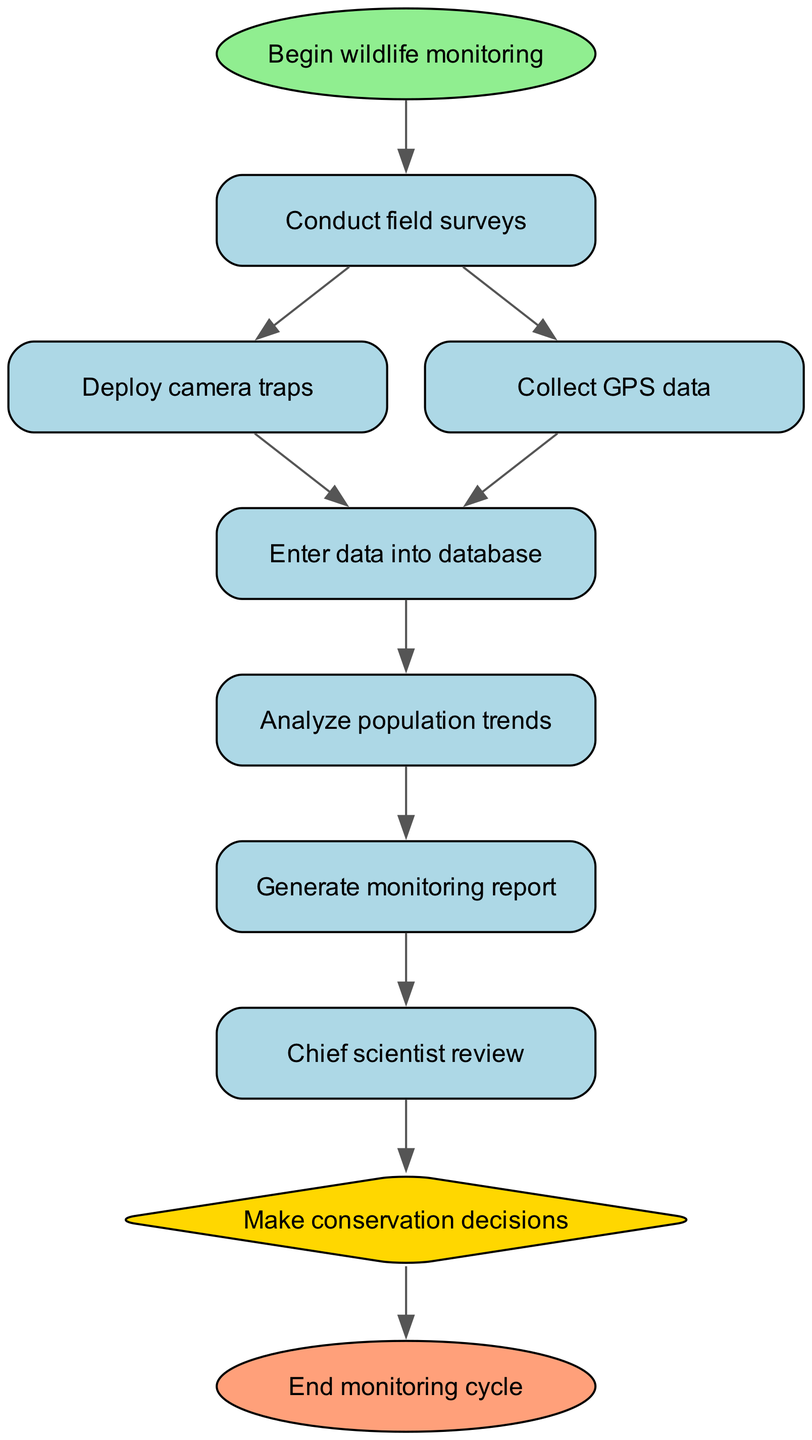What is the first step in the wildlife monitoring process? The diagram indicates that the first step is represented by the 'start' node, which states "Begin wildlife monitoring." Hence, this is the initial action taken in the process.
Answer: Begin wildlife monitoring How many nodes are present in the diagram? Counting the nodes listed, there are a total of 10 unique nodes that correspond to various steps within the wildlife monitoring process.
Answer: 10 What follows the data entry step? The diagram shows that after the 'dataEntry' node, the next process is represented by the 'analysis' node, which indicates that population trends will be analyzed after data is entered.
Answer: Analyze population trends What is the shape of the decision node? The diagram specifies that the 'decision' node is shaped as a diamond, which is a common representation for decision points in flowcharts.
Answer: Diamond How many distinct methods for data collection are outlined in the diagram? The diagram lists two separate methods for data collection: 'Conduct field surveys' and 'Deploy camera traps' in addition to 'Collect GPS data', making a total of three distinct methods illustrated in the process.
Answer: 3 Which node does the 'Chief scientist review' lead to? The 'Chief scientist review' node directly leads to the 'Make conservation decisions' node, indicating that the review is part of the decision-making process.
Answer: Make conservation decisions What is the final step in the wildlife monitoring process? The final node, labeled 'end', signifies the completion of the wildlife monitoring cycle, which indicates that all steps have been accounted for and the process is concluding.
Answer: End monitoring cycle What are the types of data collection methods mentioned before data entry occurs? The diagram indicates two specific methods prior to data entry: 'Deploy camera traps' and 'Collect GPS data', as well as 'Conduct field surveys', summing them up.
Answer: Deploy camera traps, Collect GPS data, Conduct field surveys 